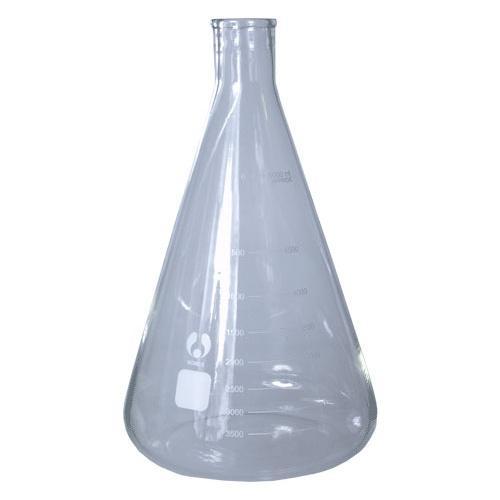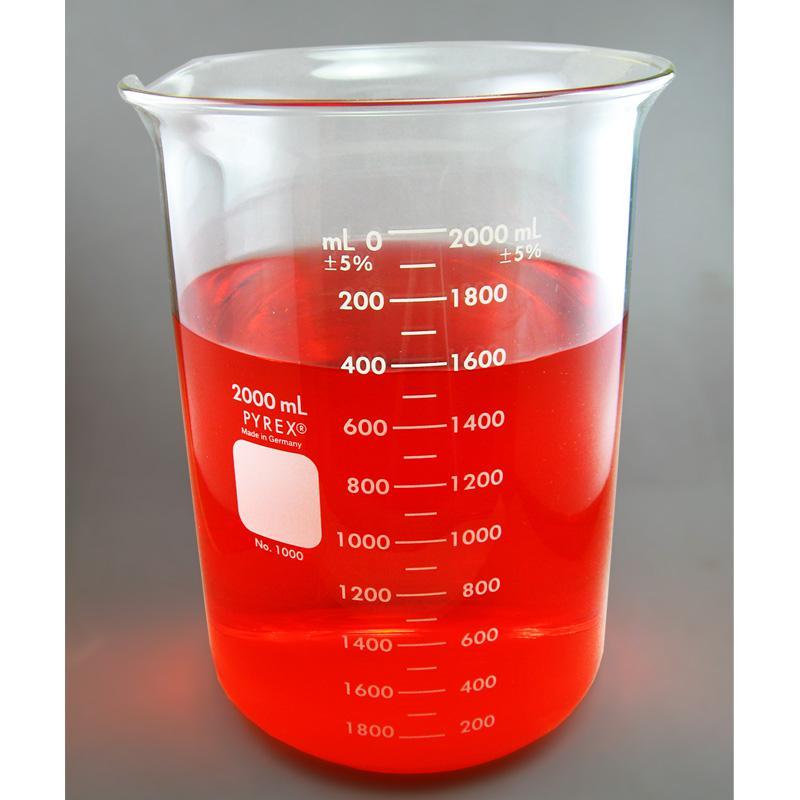The first image is the image on the left, the second image is the image on the right. Given the left and right images, does the statement "One of the images shows an empty flask and the other image shows a flask containing liquid." hold true? Answer yes or no. Yes. The first image is the image on the left, the second image is the image on the right. Given the left and right images, does the statement "One of the images contains a flask rather than a beaker." hold true? Answer yes or no. Yes. 